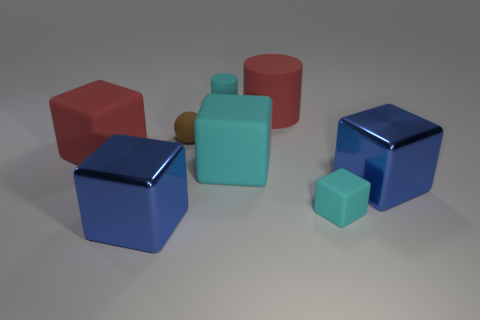Subtract 1 cubes. How many cubes are left? 4 Subtract all small blocks. How many blocks are left? 4 Subtract all gray blocks. Subtract all red cylinders. How many blocks are left? 5 Add 1 large cubes. How many objects exist? 9 Subtract all spheres. How many objects are left? 7 Subtract all large cyan cubes. Subtract all big red matte objects. How many objects are left? 5 Add 2 big cyan things. How many big cyan things are left? 3 Add 4 blue cubes. How many blue cubes exist? 6 Subtract 0 cyan balls. How many objects are left? 8 